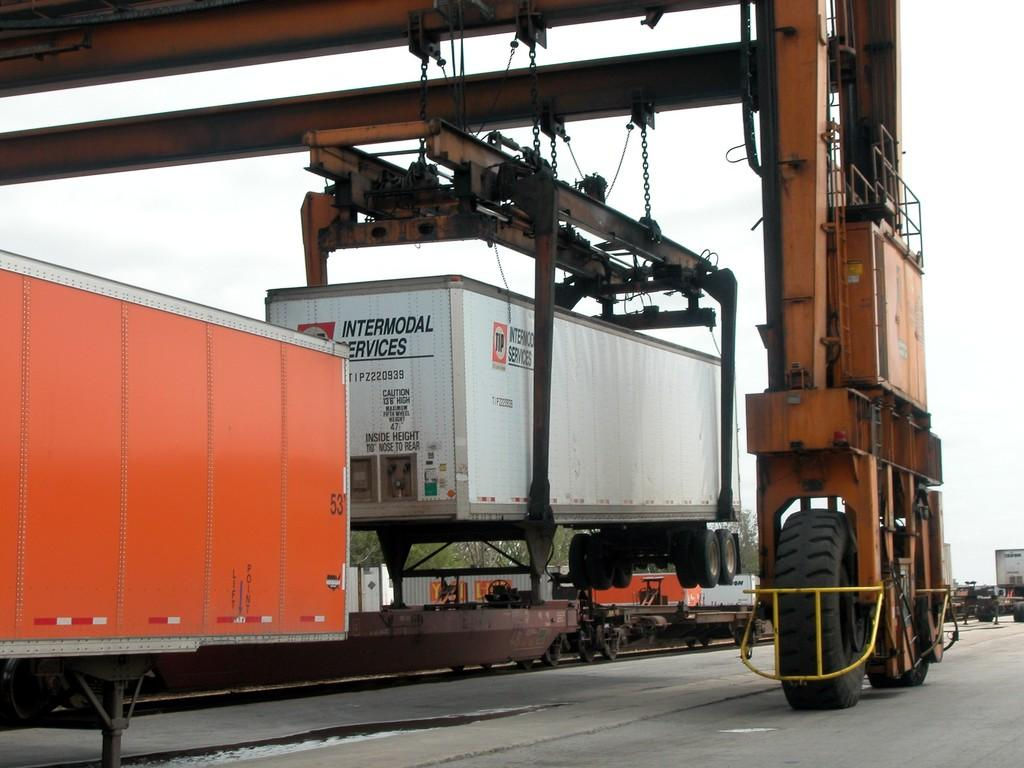What is being transported on the vehicles in the image? Containers are being transported on vehicles in the image. What type of natural environment can be seen in the image? Trees are visible in the image, indicating a natural environment. What is visible in the background of the image? The sky is visible in the image. What is the crane doing in the image? A crane is holding a container in the image. What type of glue is being used to attach the details to the sky in the image? There are no details being attached to the sky in the image, and no glue is present. 